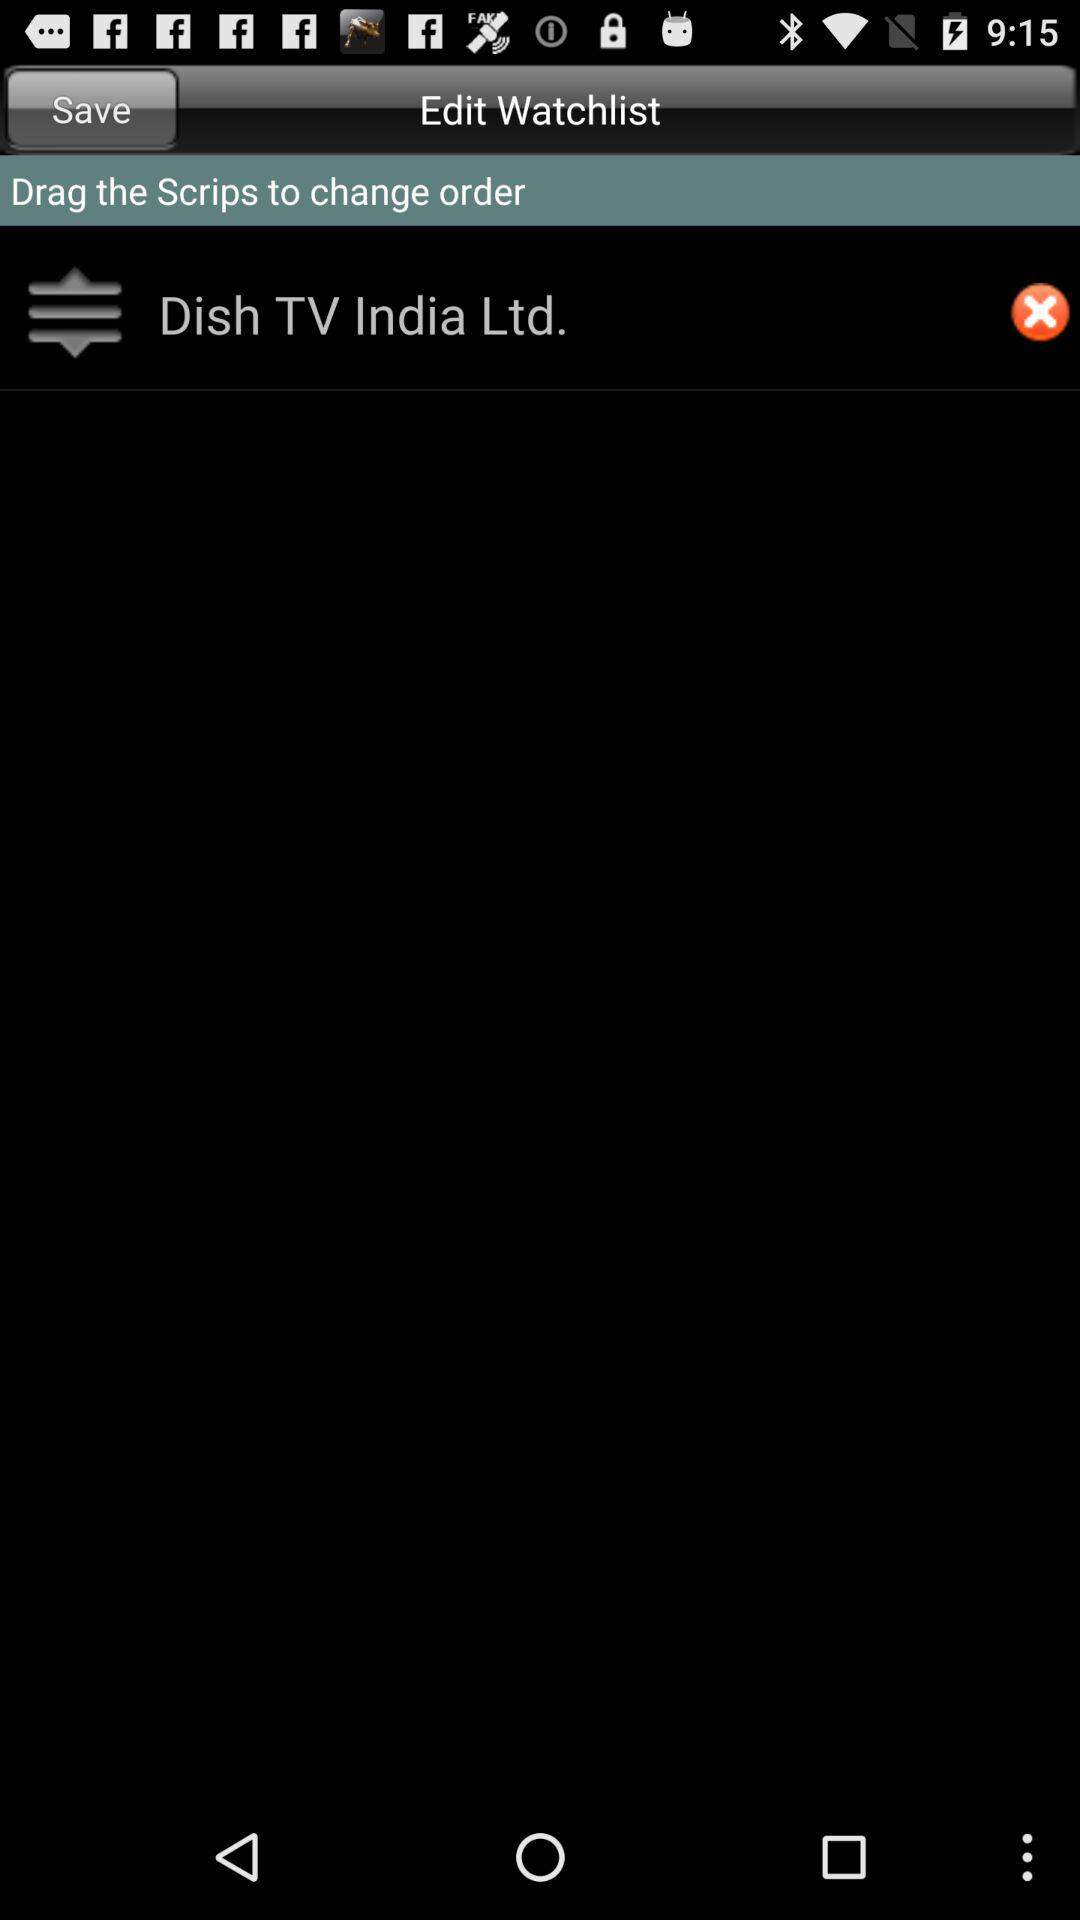Which scrip is mentioned in the watchlist? The mentioned scrip is "Dish TV India Ltd.". 